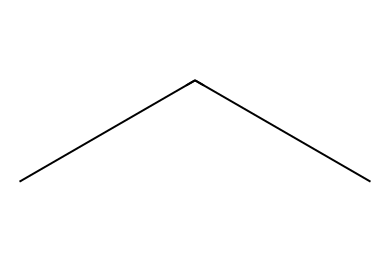What is the name of this refrigerant? The provided SMILES "CCC" corresponds to propane, which is commonly referred to as R-290 in refrigeration applications.
Answer: propane How many carbon atoms are in this chemical structure? The SMILES representation contains three "C" symbols, indicating there are three carbon atoms in the structure of propane.
Answer: three What is the molecular formula of propane? Propane consists of three carbon atoms and eight hydrogen atoms, leading to the molecular formula C3H8.
Answer: C3H8 Is propane a natural refrigerant? Yes, propane (R-290) is classified as a natural refrigerant due to its availability and lower environmental impact compared to synthetic refrigerants.
Answer: yes What property makes propane a good choice for eco-friendly refrigeration? Propane has low global warming potential (GWP), making it an environmentally friendly choice in refrigeration systems.
Answer: low global warming potential How many hydrogen atoms are bonded to the carbon atoms in propane? Each carbon atom in propane is bonded to enough hydrogen atoms to satisfy carbon's tetravalency; therefore, the three carbon atoms are bonded to eight hydrogen atoms.
Answer: eight What phase is propane in at room temperature? At room temperature, propane is typically in the gaseous phase as it has a boiling point of around -42 degrees Celsius.
Answer: gas 